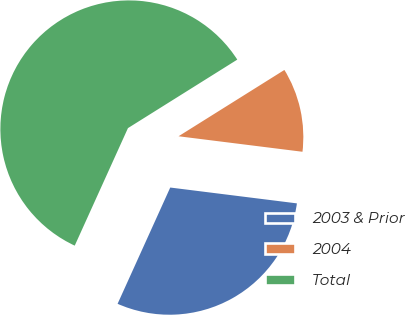<chart> <loc_0><loc_0><loc_500><loc_500><pie_chart><fcel>2003 & Prior<fcel>2004<fcel>Total<nl><fcel>29.79%<fcel>10.89%<fcel>59.33%<nl></chart> 